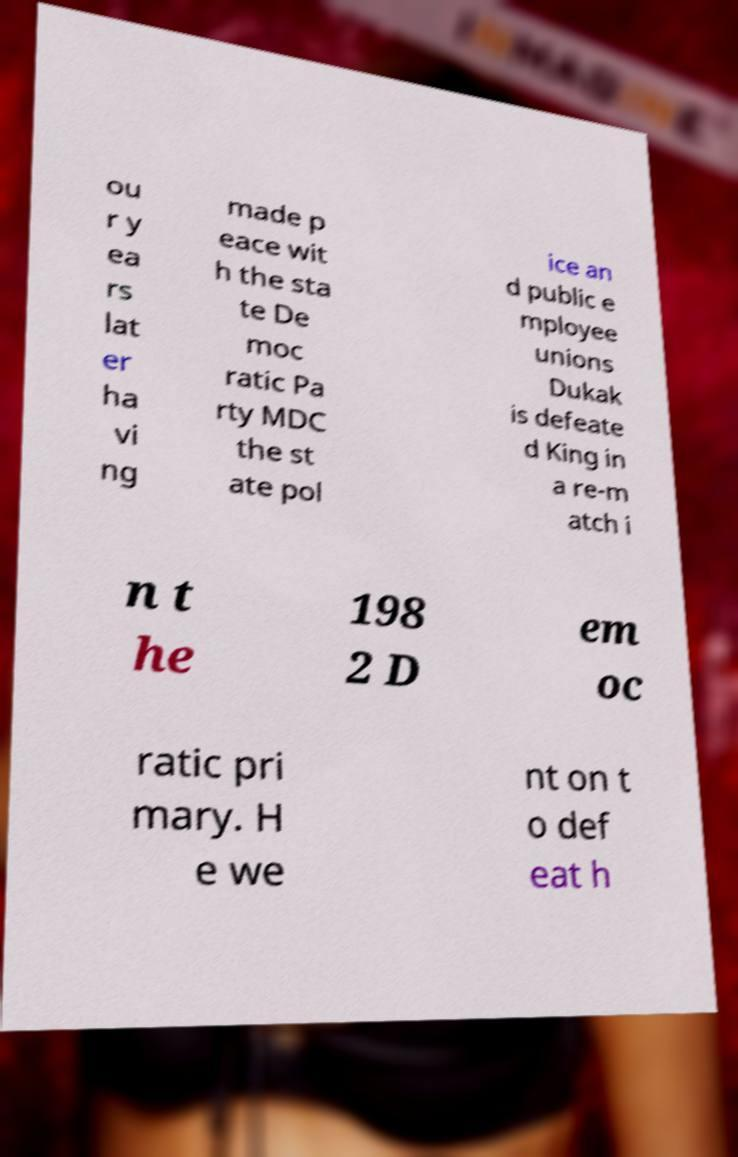I need the written content from this picture converted into text. Can you do that? ou r y ea rs lat er ha vi ng made p eace wit h the sta te De moc ratic Pa rty MDC the st ate pol ice an d public e mployee unions Dukak is defeate d King in a re-m atch i n t he 198 2 D em oc ratic pri mary. H e we nt on t o def eat h 